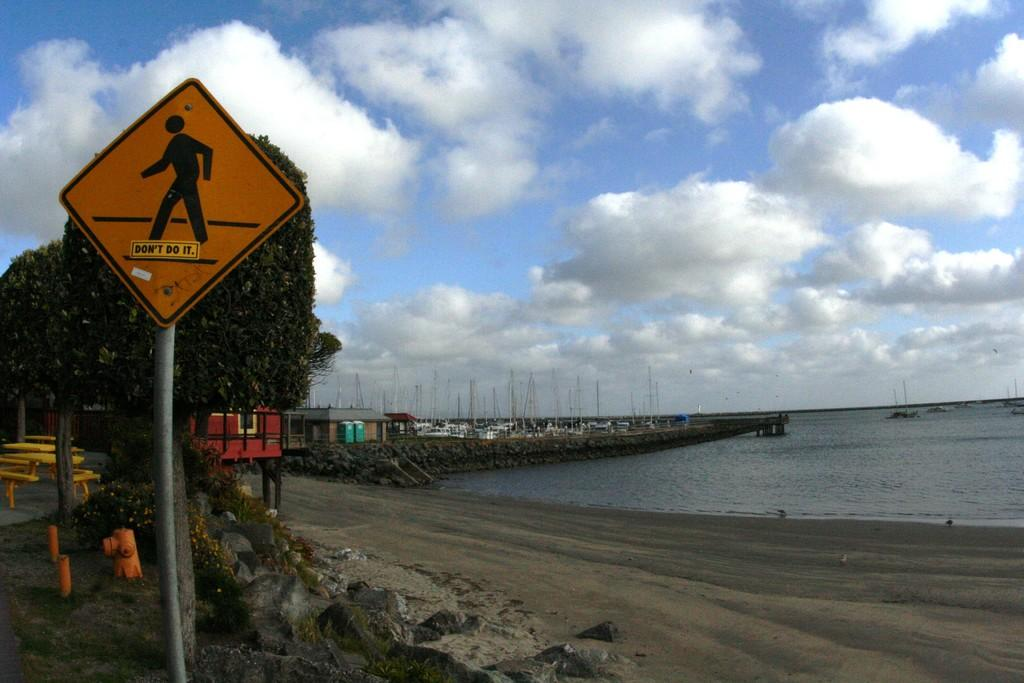<image>
Render a clear and concise summary of the photo. A sticker on the pedestrian sign says "don't do it". 